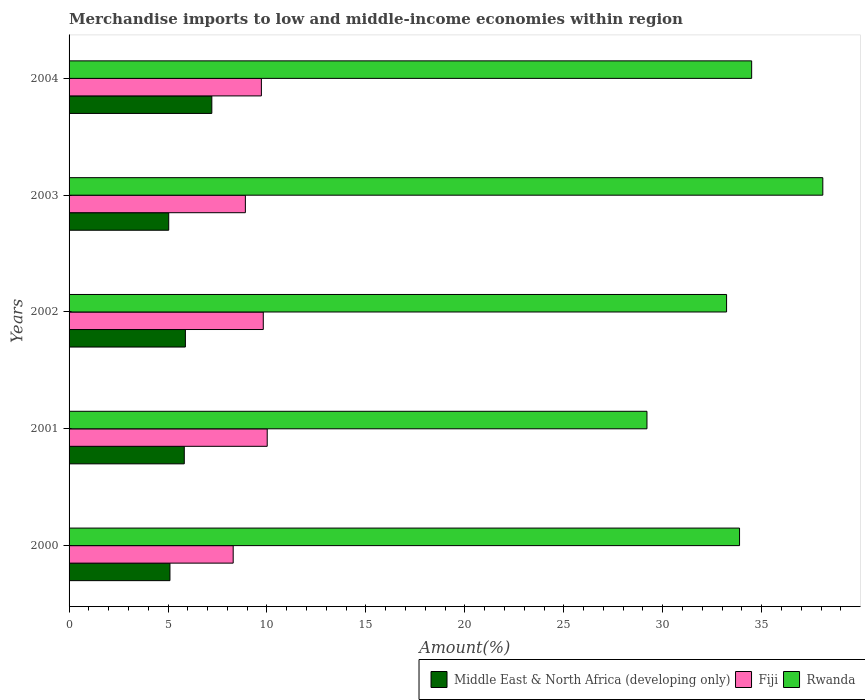Are the number of bars per tick equal to the number of legend labels?
Provide a succinct answer. Yes. Are the number of bars on each tick of the Y-axis equal?
Provide a short and direct response. Yes. How many bars are there on the 1st tick from the bottom?
Make the answer very short. 3. In how many cases, is the number of bars for a given year not equal to the number of legend labels?
Offer a very short reply. 0. What is the percentage of amount earned from merchandise imports in Middle East & North Africa (developing only) in 2001?
Make the answer very short. 5.82. Across all years, what is the maximum percentage of amount earned from merchandise imports in Middle East & North Africa (developing only)?
Your answer should be very brief. 7.21. Across all years, what is the minimum percentage of amount earned from merchandise imports in Fiji?
Ensure brevity in your answer.  8.29. What is the total percentage of amount earned from merchandise imports in Fiji in the graph?
Offer a very short reply. 46.75. What is the difference between the percentage of amount earned from merchandise imports in Fiji in 2001 and that in 2004?
Make the answer very short. 0.29. What is the difference between the percentage of amount earned from merchandise imports in Fiji in 2004 and the percentage of amount earned from merchandise imports in Rwanda in 2001?
Make the answer very short. -19.48. What is the average percentage of amount earned from merchandise imports in Fiji per year?
Your answer should be compact. 9.35. In the year 2004, what is the difference between the percentage of amount earned from merchandise imports in Fiji and percentage of amount earned from merchandise imports in Middle East & North Africa (developing only)?
Provide a succinct answer. 2.5. What is the ratio of the percentage of amount earned from merchandise imports in Fiji in 2003 to that in 2004?
Your answer should be compact. 0.92. Is the percentage of amount earned from merchandise imports in Fiji in 2000 less than that in 2001?
Offer a very short reply. Yes. What is the difference between the highest and the second highest percentage of amount earned from merchandise imports in Rwanda?
Keep it short and to the point. 3.6. What is the difference between the highest and the lowest percentage of amount earned from merchandise imports in Fiji?
Offer a very short reply. 1.72. What does the 3rd bar from the top in 2001 represents?
Make the answer very short. Middle East & North Africa (developing only). What does the 2nd bar from the bottom in 2002 represents?
Give a very brief answer. Fiji. Is it the case that in every year, the sum of the percentage of amount earned from merchandise imports in Fiji and percentage of amount earned from merchandise imports in Rwanda is greater than the percentage of amount earned from merchandise imports in Middle East & North Africa (developing only)?
Ensure brevity in your answer.  Yes. How many bars are there?
Your answer should be very brief. 15. Are the values on the major ticks of X-axis written in scientific E-notation?
Offer a terse response. No. Does the graph contain any zero values?
Give a very brief answer. No. Does the graph contain grids?
Your answer should be very brief. No. What is the title of the graph?
Ensure brevity in your answer.  Merchandise imports to low and middle-income economies within region. What is the label or title of the X-axis?
Your response must be concise. Amount(%). What is the label or title of the Y-axis?
Your response must be concise. Years. What is the Amount(%) of Middle East & North Africa (developing only) in 2000?
Ensure brevity in your answer.  5.1. What is the Amount(%) of Fiji in 2000?
Offer a terse response. 8.29. What is the Amount(%) in Rwanda in 2000?
Make the answer very short. 33.88. What is the Amount(%) in Middle East & North Africa (developing only) in 2001?
Your response must be concise. 5.82. What is the Amount(%) of Fiji in 2001?
Provide a succinct answer. 10.01. What is the Amount(%) of Rwanda in 2001?
Your response must be concise. 29.2. What is the Amount(%) in Middle East & North Africa (developing only) in 2002?
Your answer should be very brief. 5.88. What is the Amount(%) in Fiji in 2002?
Your answer should be compact. 9.81. What is the Amount(%) in Rwanda in 2002?
Keep it short and to the point. 33.23. What is the Amount(%) of Middle East & North Africa (developing only) in 2003?
Your answer should be compact. 5.04. What is the Amount(%) of Fiji in 2003?
Provide a short and direct response. 8.91. What is the Amount(%) of Rwanda in 2003?
Your answer should be very brief. 38.09. What is the Amount(%) in Middle East & North Africa (developing only) in 2004?
Provide a succinct answer. 7.21. What is the Amount(%) of Fiji in 2004?
Make the answer very short. 9.72. What is the Amount(%) in Rwanda in 2004?
Your answer should be compact. 34.49. Across all years, what is the maximum Amount(%) in Middle East & North Africa (developing only)?
Ensure brevity in your answer.  7.21. Across all years, what is the maximum Amount(%) in Fiji?
Keep it short and to the point. 10.01. Across all years, what is the maximum Amount(%) of Rwanda?
Provide a succinct answer. 38.09. Across all years, what is the minimum Amount(%) of Middle East & North Africa (developing only)?
Provide a succinct answer. 5.04. Across all years, what is the minimum Amount(%) in Fiji?
Give a very brief answer. 8.29. Across all years, what is the minimum Amount(%) of Rwanda?
Provide a short and direct response. 29.2. What is the total Amount(%) of Middle East & North Africa (developing only) in the graph?
Give a very brief answer. 29.05. What is the total Amount(%) of Fiji in the graph?
Provide a short and direct response. 46.75. What is the total Amount(%) of Rwanda in the graph?
Provide a succinct answer. 168.9. What is the difference between the Amount(%) of Middle East & North Africa (developing only) in 2000 and that in 2001?
Offer a terse response. -0.72. What is the difference between the Amount(%) in Fiji in 2000 and that in 2001?
Make the answer very short. -1.72. What is the difference between the Amount(%) of Rwanda in 2000 and that in 2001?
Your answer should be compact. 4.68. What is the difference between the Amount(%) in Middle East & North Africa (developing only) in 2000 and that in 2002?
Ensure brevity in your answer.  -0.78. What is the difference between the Amount(%) of Fiji in 2000 and that in 2002?
Provide a short and direct response. -1.52. What is the difference between the Amount(%) of Rwanda in 2000 and that in 2002?
Ensure brevity in your answer.  0.66. What is the difference between the Amount(%) in Middle East & North Africa (developing only) in 2000 and that in 2003?
Offer a terse response. 0.06. What is the difference between the Amount(%) in Fiji in 2000 and that in 2003?
Keep it short and to the point. -0.62. What is the difference between the Amount(%) in Rwanda in 2000 and that in 2003?
Offer a very short reply. -4.21. What is the difference between the Amount(%) in Middle East & North Africa (developing only) in 2000 and that in 2004?
Ensure brevity in your answer.  -2.12. What is the difference between the Amount(%) in Fiji in 2000 and that in 2004?
Provide a succinct answer. -1.43. What is the difference between the Amount(%) in Rwanda in 2000 and that in 2004?
Your answer should be compact. -0.61. What is the difference between the Amount(%) of Middle East & North Africa (developing only) in 2001 and that in 2002?
Your response must be concise. -0.06. What is the difference between the Amount(%) in Fiji in 2001 and that in 2002?
Your answer should be very brief. 0.2. What is the difference between the Amount(%) of Rwanda in 2001 and that in 2002?
Offer a very short reply. -4.02. What is the difference between the Amount(%) of Middle East & North Africa (developing only) in 2001 and that in 2003?
Your answer should be very brief. 0.79. What is the difference between the Amount(%) of Fiji in 2001 and that in 2003?
Provide a succinct answer. 1.1. What is the difference between the Amount(%) in Rwanda in 2001 and that in 2003?
Make the answer very short. -8.89. What is the difference between the Amount(%) of Middle East & North Africa (developing only) in 2001 and that in 2004?
Ensure brevity in your answer.  -1.39. What is the difference between the Amount(%) in Fiji in 2001 and that in 2004?
Give a very brief answer. 0.29. What is the difference between the Amount(%) in Rwanda in 2001 and that in 2004?
Provide a short and direct response. -5.29. What is the difference between the Amount(%) of Middle East & North Africa (developing only) in 2002 and that in 2003?
Offer a very short reply. 0.84. What is the difference between the Amount(%) of Fiji in 2002 and that in 2003?
Keep it short and to the point. 0.91. What is the difference between the Amount(%) of Rwanda in 2002 and that in 2003?
Make the answer very short. -4.86. What is the difference between the Amount(%) in Middle East & North Africa (developing only) in 2002 and that in 2004?
Offer a terse response. -1.34. What is the difference between the Amount(%) in Fiji in 2002 and that in 2004?
Offer a very short reply. 0.1. What is the difference between the Amount(%) in Rwanda in 2002 and that in 2004?
Make the answer very short. -1.27. What is the difference between the Amount(%) of Middle East & North Africa (developing only) in 2003 and that in 2004?
Provide a short and direct response. -2.18. What is the difference between the Amount(%) in Fiji in 2003 and that in 2004?
Offer a very short reply. -0.81. What is the difference between the Amount(%) of Rwanda in 2003 and that in 2004?
Your answer should be compact. 3.6. What is the difference between the Amount(%) of Middle East & North Africa (developing only) in 2000 and the Amount(%) of Fiji in 2001?
Your answer should be compact. -4.92. What is the difference between the Amount(%) in Middle East & North Africa (developing only) in 2000 and the Amount(%) in Rwanda in 2001?
Ensure brevity in your answer.  -24.11. What is the difference between the Amount(%) in Fiji in 2000 and the Amount(%) in Rwanda in 2001?
Offer a very short reply. -20.91. What is the difference between the Amount(%) of Middle East & North Africa (developing only) in 2000 and the Amount(%) of Fiji in 2002?
Your answer should be compact. -4.72. What is the difference between the Amount(%) in Middle East & North Africa (developing only) in 2000 and the Amount(%) in Rwanda in 2002?
Your answer should be compact. -28.13. What is the difference between the Amount(%) in Fiji in 2000 and the Amount(%) in Rwanda in 2002?
Your answer should be compact. -24.93. What is the difference between the Amount(%) of Middle East & North Africa (developing only) in 2000 and the Amount(%) of Fiji in 2003?
Provide a short and direct response. -3.81. What is the difference between the Amount(%) in Middle East & North Africa (developing only) in 2000 and the Amount(%) in Rwanda in 2003?
Provide a succinct answer. -32.99. What is the difference between the Amount(%) in Fiji in 2000 and the Amount(%) in Rwanda in 2003?
Your response must be concise. -29.8. What is the difference between the Amount(%) of Middle East & North Africa (developing only) in 2000 and the Amount(%) of Fiji in 2004?
Your response must be concise. -4.62. What is the difference between the Amount(%) of Middle East & North Africa (developing only) in 2000 and the Amount(%) of Rwanda in 2004?
Your response must be concise. -29.4. What is the difference between the Amount(%) in Fiji in 2000 and the Amount(%) in Rwanda in 2004?
Your response must be concise. -26.2. What is the difference between the Amount(%) in Middle East & North Africa (developing only) in 2001 and the Amount(%) in Fiji in 2002?
Offer a very short reply. -3.99. What is the difference between the Amount(%) in Middle East & North Africa (developing only) in 2001 and the Amount(%) in Rwanda in 2002?
Offer a very short reply. -27.4. What is the difference between the Amount(%) of Fiji in 2001 and the Amount(%) of Rwanda in 2002?
Keep it short and to the point. -23.21. What is the difference between the Amount(%) in Middle East & North Africa (developing only) in 2001 and the Amount(%) in Fiji in 2003?
Your response must be concise. -3.09. What is the difference between the Amount(%) in Middle East & North Africa (developing only) in 2001 and the Amount(%) in Rwanda in 2003?
Provide a short and direct response. -32.27. What is the difference between the Amount(%) of Fiji in 2001 and the Amount(%) of Rwanda in 2003?
Provide a short and direct response. -28.08. What is the difference between the Amount(%) in Middle East & North Africa (developing only) in 2001 and the Amount(%) in Fiji in 2004?
Provide a short and direct response. -3.9. What is the difference between the Amount(%) in Middle East & North Africa (developing only) in 2001 and the Amount(%) in Rwanda in 2004?
Your response must be concise. -28.67. What is the difference between the Amount(%) in Fiji in 2001 and the Amount(%) in Rwanda in 2004?
Offer a terse response. -24.48. What is the difference between the Amount(%) in Middle East & North Africa (developing only) in 2002 and the Amount(%) in Fiji in 2003?
Offer a terse response. -3.03. What is the difference between the Amount(%) of Middle East & North Africa (developing only) in 2002 and the Amount(%) of Rwanda in 2003?
Your answer should be very brief. -32.21. What is the difference between the Amount(%) of Fiji in 2002 and the Amount(%) of Rwanda in 2003?
Give a very brief answer. -28.27. What is the difference between the Amount(%) in Middle East & North Africa (developing only) in 2002 and the Amount(%) in Fiji in 2004?
Provide a succinct answer. -3.84. What is the difference between the Amount(%) of Middle East & North Africa (developing only) in 2002 and the Amount(%) of Rwanda in 2004?
Provide a short and direct response. -28.62. What is the difference between the Amount(%) of Fiji in 2002 and the Amount(%) of Rwanda in 2004?
Your answer should be compact. -24.68. What is the difference between the Amount(%) in Middle East & North Africa (developing only) in 2003 and the Amount(%) in Fiji in 2004?
Give a very brief answer. -4.68. What is the difference between the Amount(%) of Middle East & North Africa (developing only) in 2003 and the Amount(%) of Rwanda in 2004?
Provide a succinct answer. -29.46. What is the difference between the Amount(%) of Fiji in 2003 and the Amount(%) of Rwanda in 2004?
Your answer should be compact. -25.58. What is the average Amount(%) of Middle East & North Africa (developing only) per year?
Offer a terse response. 5.81. What is the average Amount(%) of Fiji per year?
Your answer should be compact. 9.35. What is the average Amount(%) of Rwanda per year?
Offer a terse response. 33.78. In the year 2000, what is the difference between the Amount(%) in Middle East & North Africa (developing only) and Amount(%) in Fiji?
Your response must be concise. -3.2. In the year 2000, what is the difference between the Amount(%) in Middle East & North Africa (developing only) and Amount(%) in Rwanda?
Offer a very short reply. -28.78. In the year 2000, what is the difference between the Amount(%) in Fiji and Amount(%) in Rwanda?
Provide a succinct answer. -25.59. In the year 2001, what is the difference between the Amount(%) in Middle East & North Africa (developing only) and Amount(%) in Fiji?
Ensure brevity in your answer.  -4.19. In the year 2001, what is the difference between the Amount(%) of Middle East & North Africa (developing only) and Amount(%) of Rwanda?
Provide a succinct answer. -23.38. In the year 2001, what is the difference between the Amount(%) in Fiji and Amount(%) in Rwanda?
Your answer should be compact. -19.19. In the year 2002, what is the difference between the Amount(%) of Middle East & North Africa (developing only) and Amount(%) of Fiji?
Your answer should be very brief. -3.94. In the year 2002, what is the difference between the Amount(%) in Middle East & North Africa (developing only) and Amount(%) in Rwanda?
Offer a very short reply. -27.35. In the year 2002, what is the difference between the Amount(%) in Fiji and Amount(%) in Rwanda?
Provide a succinct answer. -23.41. In the year 2003, what is the difference between the Amount(%) of Middle East & North Africa (developing only) and Amount(%) of Fiji?
Your answer should be very brief. -3.87. In the year 2003, what is the difference between the Amount(%) of Middle East & North Africa (developing only) and Amount(%) of Rwanda?
Keep it short and to the point. -33.05. In the year 2003, what is the difference between the Amount(%) of Fiji and Amount(%) of Rwanda?
Your response must be concise. -29.18. In the year 2004, what is the difference between the Amount(%) in Middle East & North Africa (developing only) and Amount(%) in Fiji?
Make the answer very short. -2.5. In the year 2004, what is the difference between the Amount(%) in Middle East & North Africa (developing only) and Amount(%) in Rwanda?
Your answer should be compact. -27.28. In the year 2004, what is the difference between the Amount(%) in Fiji and Amount(%) in Rwanda?
Provide a short and direct response. -24.77. What is the ratio of the Amount(%) of Middle East & North Africa (developing only) in 2000 to that in 2001?
Offer a very short reply. 0.88. What is the ratio of the Amount(%) in Fiji in 2000 to that in 2001?
Ensure brevity in your answer.  0.83. What is the ratio of the Amount(%) in Rwanda in 2000 to that in 2001?
Keep it short and to the point. 1.16. What is the ratio of the Amount(%) in Middle East & North Africa (developing only) in 2000 to that in 2002?
Offer a terse response. 0.87. What is the ratio of the Amount(%) in Fiji in 2000 to that in 2002?
Provide a succinct answer. 0.84. What is the ratio of the Amount(%) in Rwanda in 2000 to that in 2002?
Keep it short and to the point. 1.02. What is the ratio of the Amount(%) of Middle East & North Africa (developing only) in 2000 to that in 2003?
Provide a short and direct response. 1.01. What is the ratio of the Amount(%) of Fiji in 2000 to that in 2003?
Offer a terse response. 0.93. What is the ratio of the Amount(%) of Rwanda in 2000 to that in 2003?
Offer a very short reply. 0.89. What is the ratio of the Amount(%) in Middle East & North Africa (developing only) in 2000 to that in 2004?
Your answer should be compact. 0.71. What is the ratio of the Amount(%) in Fiji in 2000 to that in 2004?
Provide a succinct answer. 0.85. What is the ratio of the Amount(%) of Rwanda in 2000 to that in 2004?
Give a very brief answer. 0.98. What is the ratio of the Amount(%) of Fiji in 2001 to that in 2002?
Make the answer very short. 1.02. What is the ratio of the Amount(%) of Rwanda in 2001 to that in 2002?
Your response must be concise. 0.88. What is the ratio of the Amount(%) of Middle East & North Africa (developing only) in 2001 to that in 2003?
Give a very brief answer. 1.16. What is the ratio of the Amount(%) in Fiji in 2001 to that in 2003?
Offer a terse response. 1.12. What is the ratio of the Amount(%) in Rwanda in 2001 to that in 2003?
Your response must be concise. 0.77. What is the ratio of the Amount(%) of Middle East & North Africa (developing only) in 2001 to that in 2004?
Offer a very short reply. 0.81. What is the ratio of the Amount(%) of Fiji in 2001 to that in 2004?
Give a very brief answer. 1.03. What is the ratio of the Amount(%) in Rwanda in 2001 to that in 2004?
Make the answer very short. 0.85. What is the ratio of the Amount(%) in Middle East & North Africa (developing only) in 2002 to that in 2003?
Your answer should be compact. 1.17. What is the ratio of the Amount(%) in Fiji in 2002 to that in 2003?
Your response must be concise. 1.1. What is the ratio of the Amount(%) of Rwanda in 2002 to that in 2003?
Offer a terse response. 0.87. What is the ratio of the Amount(%) in Middle East & North Africa (developing only) in 2002 to that in 2004?
Give a very brief answer. 0.81. What is the ratio of the Amount(%) in Fiji in 2002 to that in 2004?
Make the answer very short. 1.01. What is the ratio of the Amount(%) of Rwanda in 2002 to that in 2004?
Ensure brevity in your answer.  0.96. What is the ratio of the Amount(%) in Middle East & North Africa (developing only) in 2003 to that in 2004?
Keep it short and to the point. 0.7. What is the ratio of the Amount(%) in Fiji in 2003 to that in 2004?
Offer a terse response. 0.92. What is the ratio of the Amount(%) in Rwanda in 2003 to that in 2004?
Your answer should be compact. 1.1. What is the difference between the highest and the second highest Amount(%) in Middle East & North Africa (developing only)?
Offer a very short reply. 1.34. What is the difference between the highest and the second highest Amount(%) of Fiji?
Offer a terse response. 0.2. What is the difference between the highest and the second highest Amount(%) in Rwanda?
Offer a very short reply. 3.6. What is the difference between the highest and the lowest Amount(%) in Middle East & North Africa (developing only)?
Keep it short and to the point. 2.18. What is the difference between the highest and the lowest Amount(%) of Fiji?
Keep it short and to the point. 1.72. What is the difference between the highest and the lowest Amount(%) in Rwanda?
Keep it short and to the point. 8.89. 